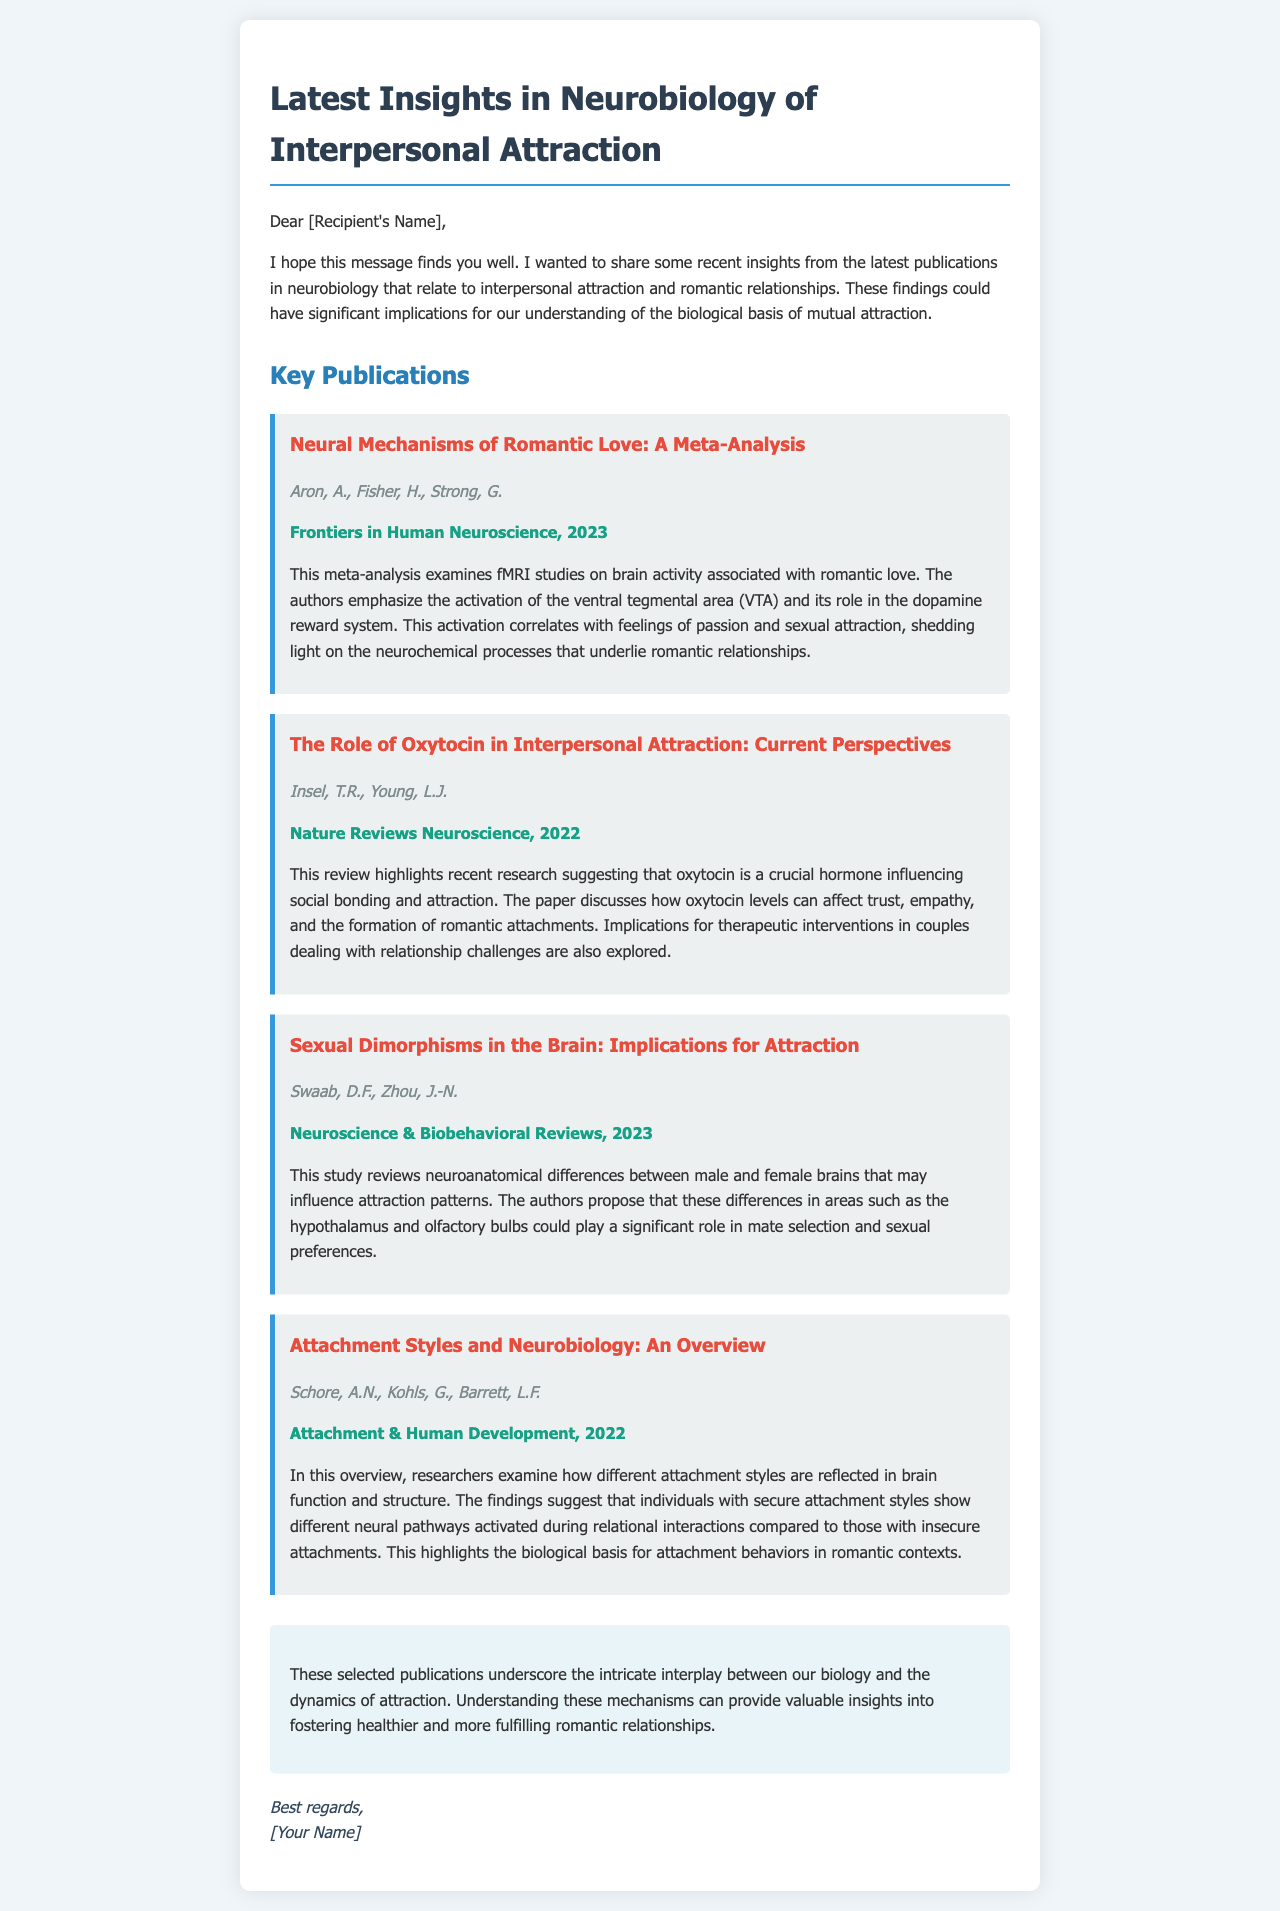What is the title of the first publication listed? The title of the first publication is presented in the document under the section "Key Publications."
Answer: Neural Mechanisms of Romantic Love: A Meta-Analysis Who are the authors of the second publication? The authors of the second publication are listed directly under its title in the document.
Answer: Insel, T.R., Young, L.J In which journal was the article "Sexual Dimorphisms in the Brain: Implications for Attraction" published? The journal in which the article was published is mentioned after the authors in the publication section.
Answer: Neuroscience & Biobehavioral Reviews What year was the publication "Attachment Styles and Neurobiology: An Overview" released? The publication year is included in the citation below the title of the article in the document.
Answer: 2022 What hormone is discussed as influencing social bonding and attraction? The relevant hormone is identified in the title of the second publication and elaborated on in its summary.
Answer: Oxytocin How many publications are summarized in the email? The number of publications can be counted from the sections provided in the "Key Publications."
Answer: Four What is the focus of the meta-analysis by Aron et al.? The main focus of the meta-analysis is addressed in its summary within the document.
Answer: Brain activity associated with romantic love What implications are explored in the second publication related to oxytocin? The implications are detailed in the summary of the publication focusing on oxytocin's effects.
Answer: Therapeutic interventions in couples What common theme connects the listed publications? The common theme is highlighted in the conclusion section summarizing the insights from the publications.
Answer: Biological basis of attraction 